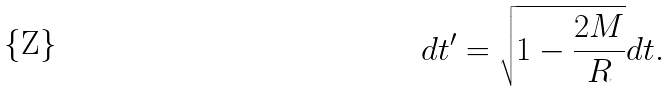Convert formula to latex. <formula><loc_0><loc_0><loc_500><loc_500>d t ^ { \prime } = \sqrt { 1 - \frac { 2 M } { R } } d t .</formula> 